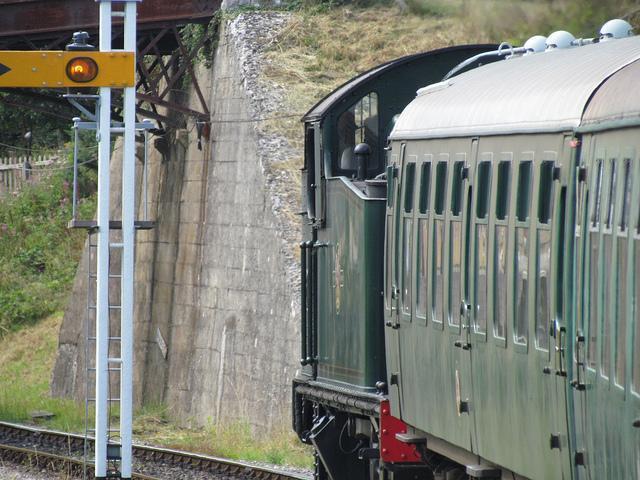How many people are wearing a tie?
Give a very brief answer. 0. 